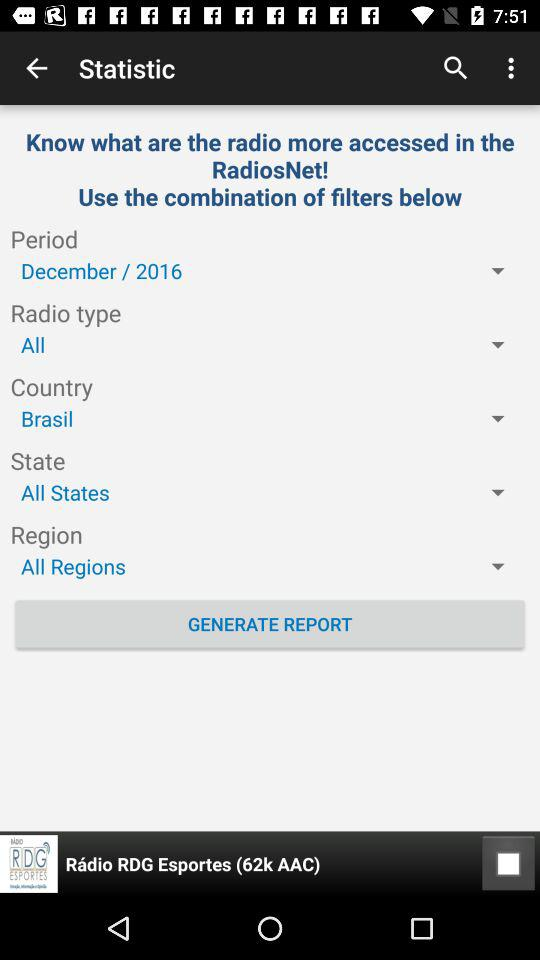What is the selected radio type? The selected radio type is "All". 